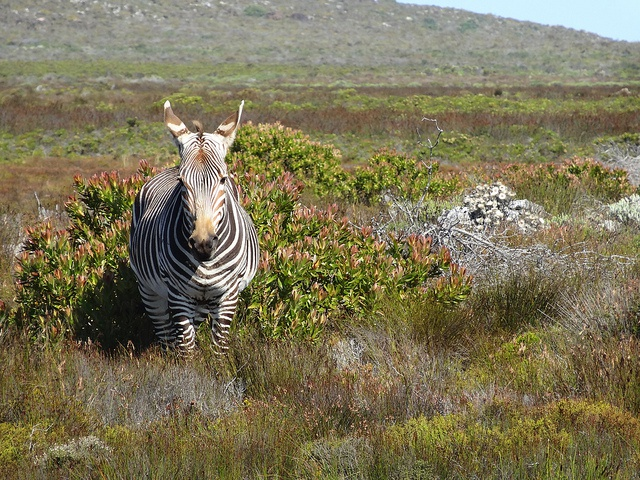Describe the objects in this image and their specific colors. I can see a zebra in gray, black, white, and darkgray tones in this image. 